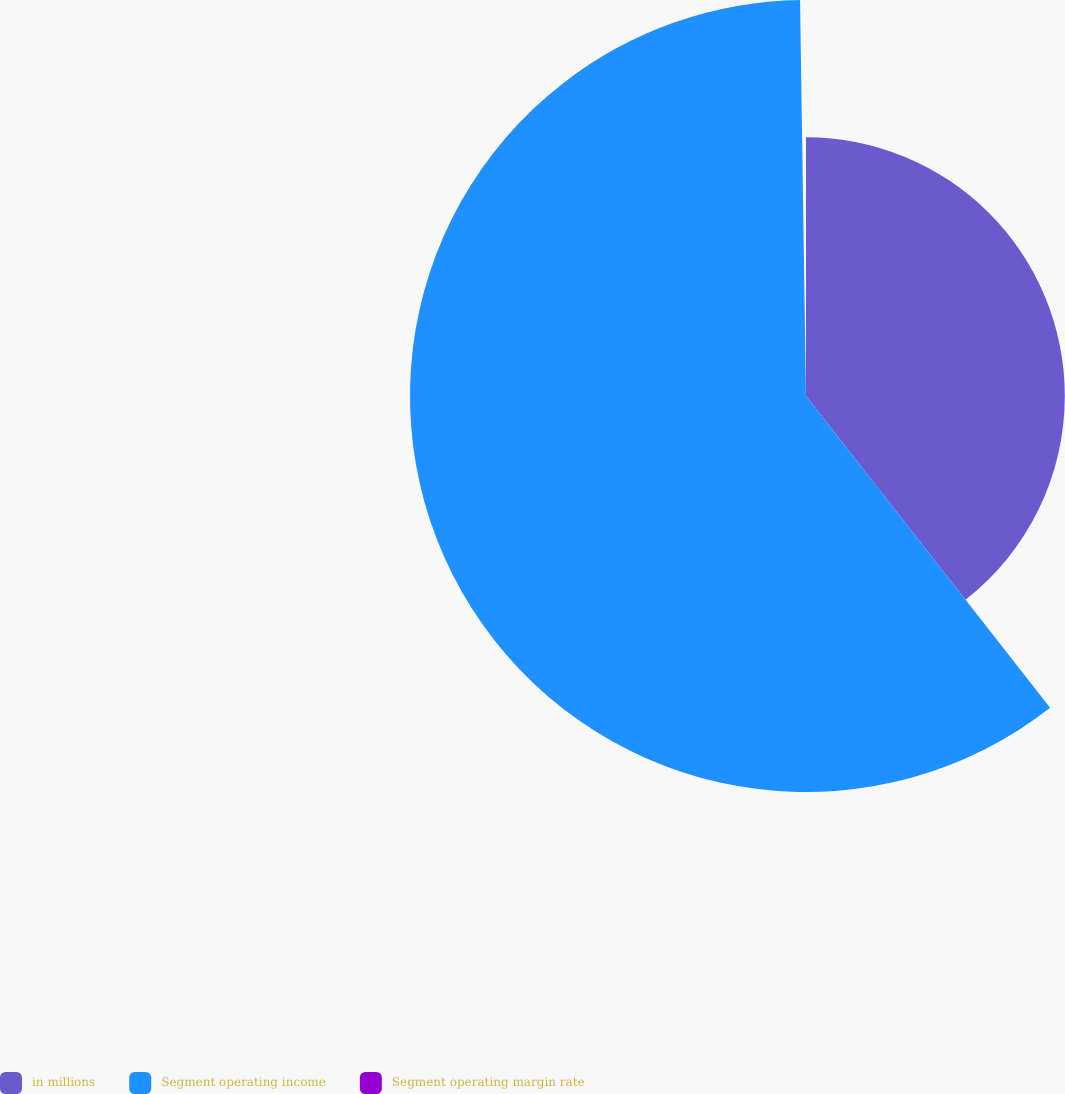Convert chart. <chart><loc_0><loc_0><loc_500><loc_500><pie_chart><fcel>in millions<fcel>Segment operating income<fcel>Segment operating margin rate<nl><fcel>39.43%<fcel>60.33%<fcel>0.24%<nl></chart> 